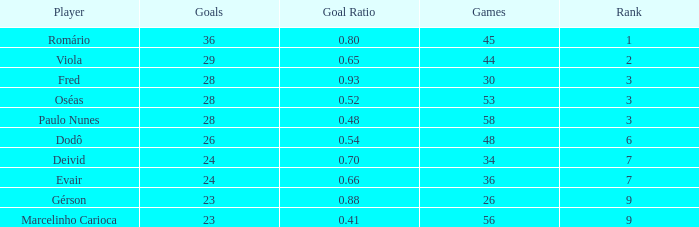How many goals have a goal ration less than 0.8 with 56 games? 1.0. 